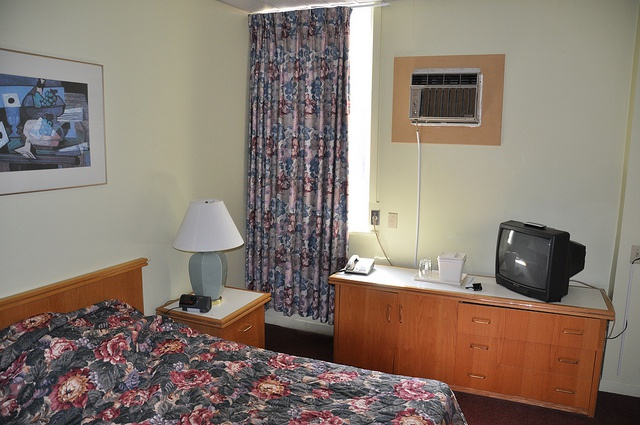Describe the objects in this image and their specific colors. I can see bed in gray, black, maroon, and brown tones, tv in gray, black, and darkgray tones, cup in gray, darkgray, and lightgray tones, and remote in gray, darkgray, and black tones in this image. 